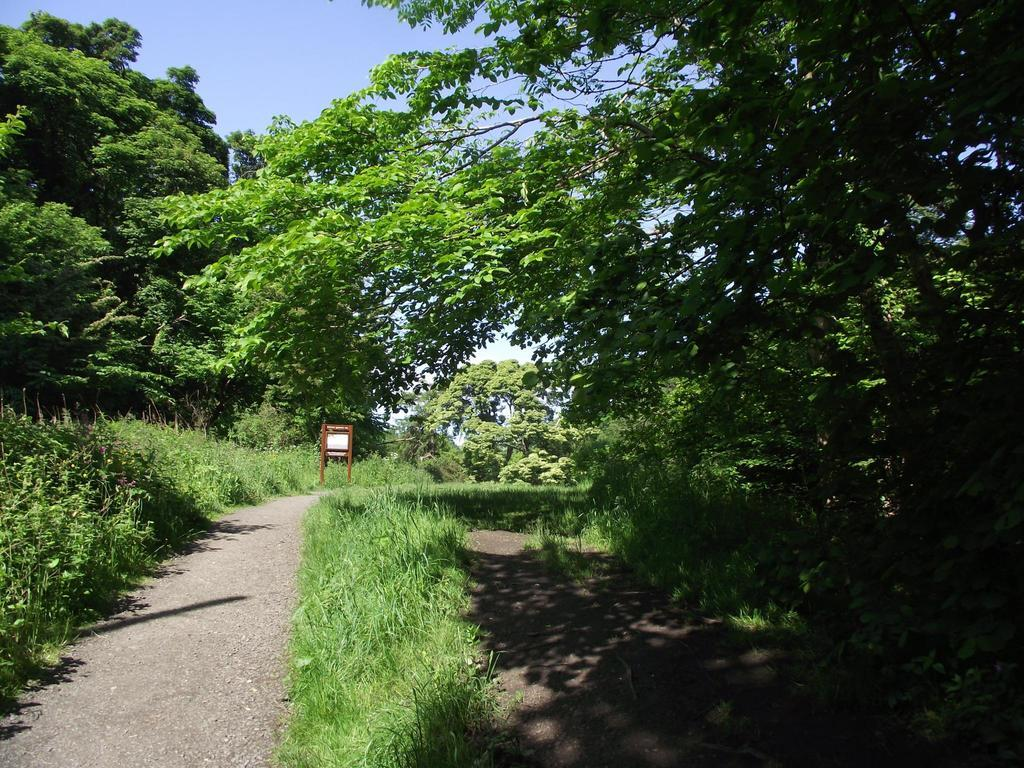What type of vegetation can be seen in the image? There is grass and plants in the image. What kind of surface is visible in the image? There is a path and the ground visible in the image. What other natural elements are present in the image? There are trees in the image. What else can be seen in the image besides the vegetation and path? There is an unspecified object in the image. What is visible in the background of the image? The sky is visible in the background of the image. How does the frog contribute to the wealth of the people in the image? There is no frog present in the image, and therefore no such contribution can be observed. What type of wheel is visible in the image? There is no wheel present in the image. 